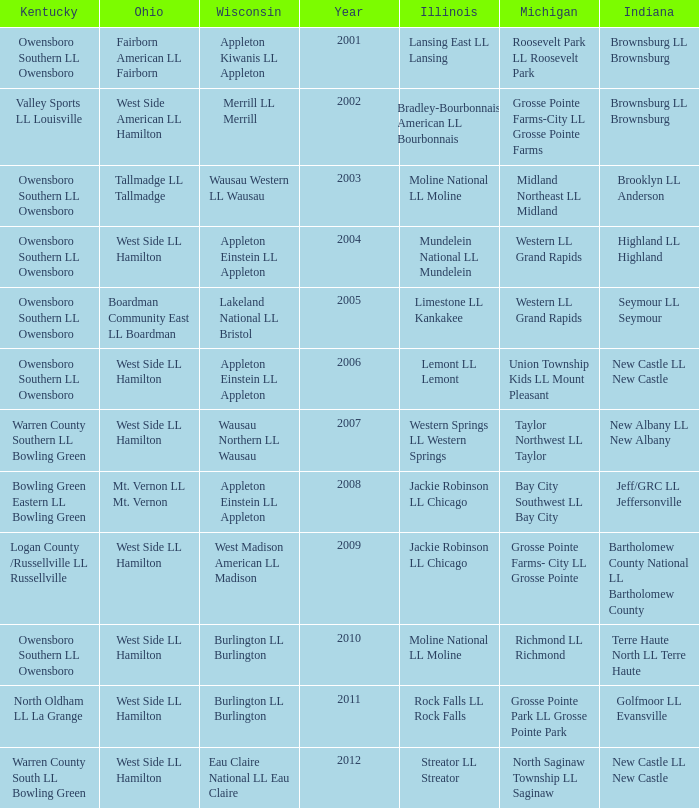What was the little league team from Ohio when the little league team from Kentucky was Warren County South LL Bowling Green? West Side LL Hamilton. 